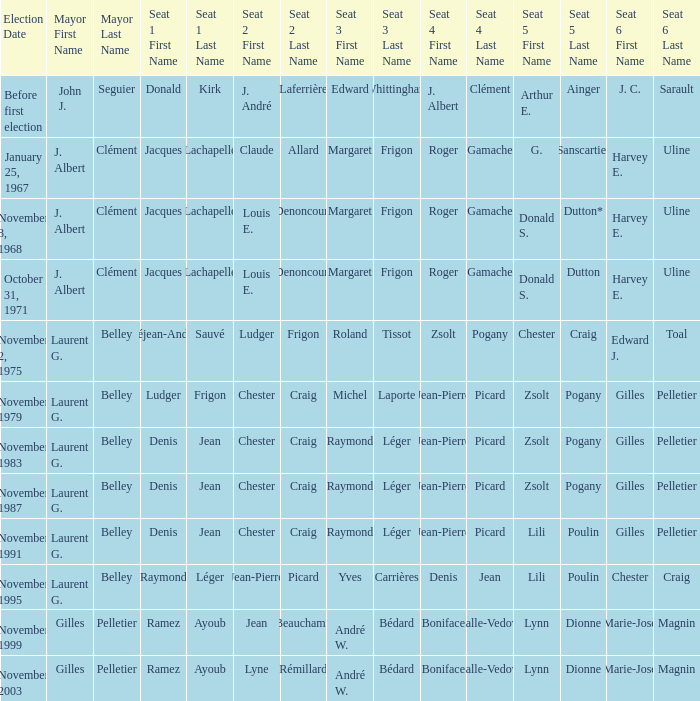Who was seat no 6 when seat no 1 and seat no 5 were jacques lachapelle and donald s. dutton Harvey E. Uline. 